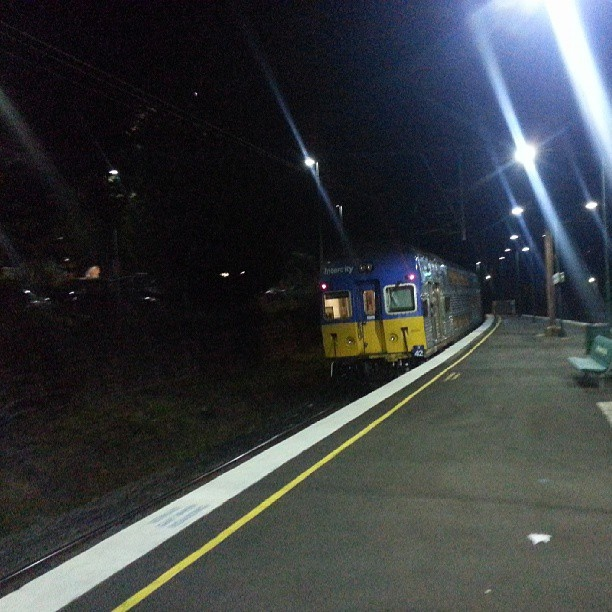Describe the objects in this image and their specific colors. I can see train in black, gray, olive, and navy tones and bench in black, teal, and darkgray tones in this image. 